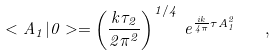<formula> <loc_0><loc_0><loc_500><loc_500>< A _ { 1 } | 0 > = \left ( \frac { k \tau _ { 2 } } { 2 \pi ^ { 2 } } \right ) ^ { 1 / 4 } \, e ^ { \frac { i k } { 4 \pi } \tau A _ { 1 } ^ { 2 } } \quad ,</formula> 